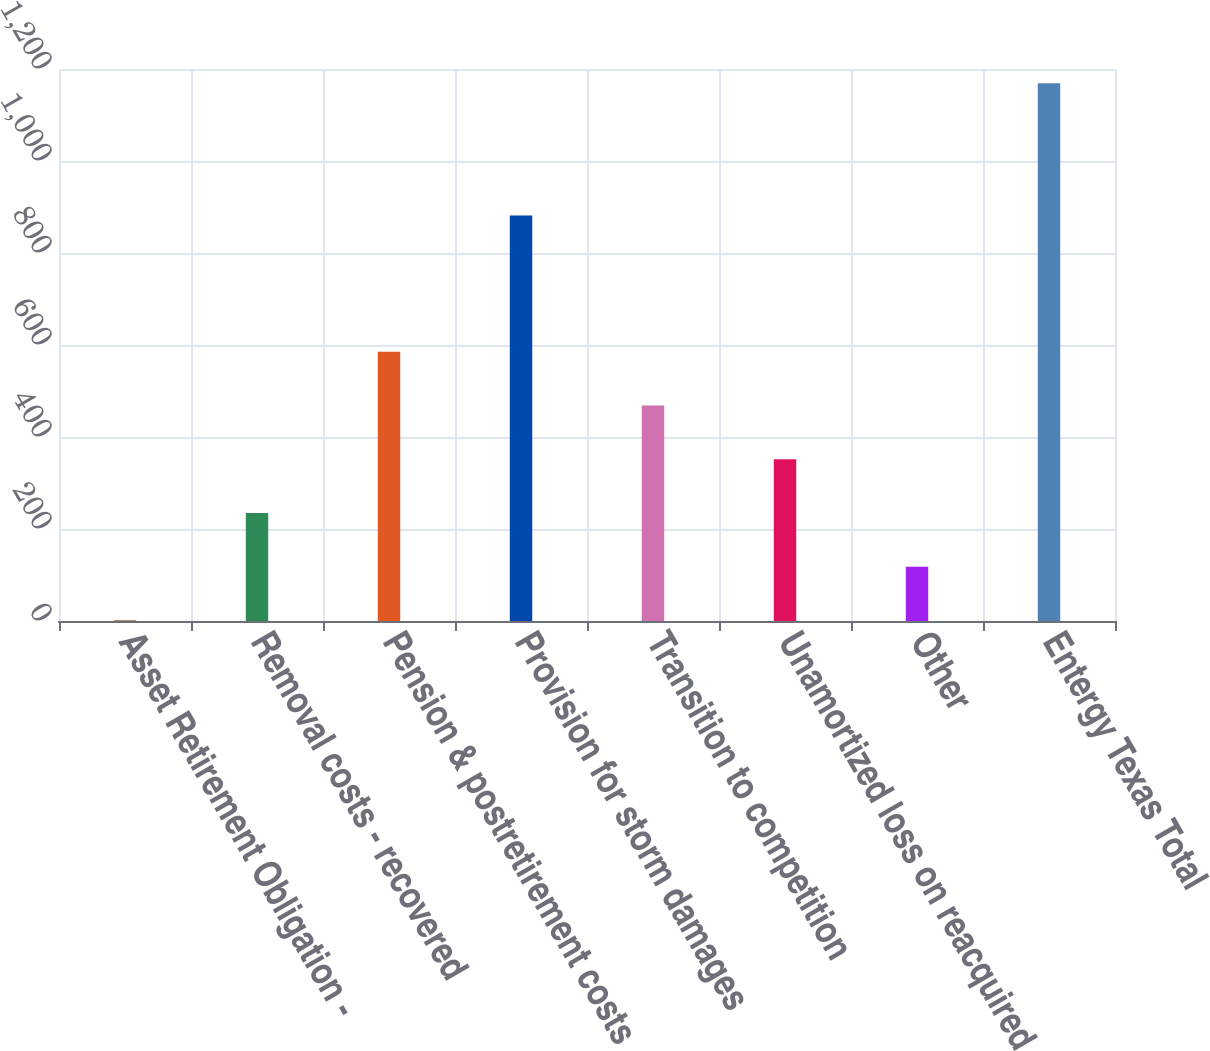<chart> <loc_0><loc_0><loc_500><loc_500><bar_chart><fcel>Asset Retirement Obligation -<fcel>Removal costs - recovered<fcel>Pension & postretirement costs<fcel>Provision for storm damages<fcel>Transition to competition<fcel>Unamortized loss on reacquired<fcel>Other<fcel>Entergy Texas Total<nl><fcel>1.4<fcel>234.92<fcel>585.2<fcel>881.7<fcel>468.44<fcel>351.68<fcel>118.16<fcel>1169<nl></chart> 